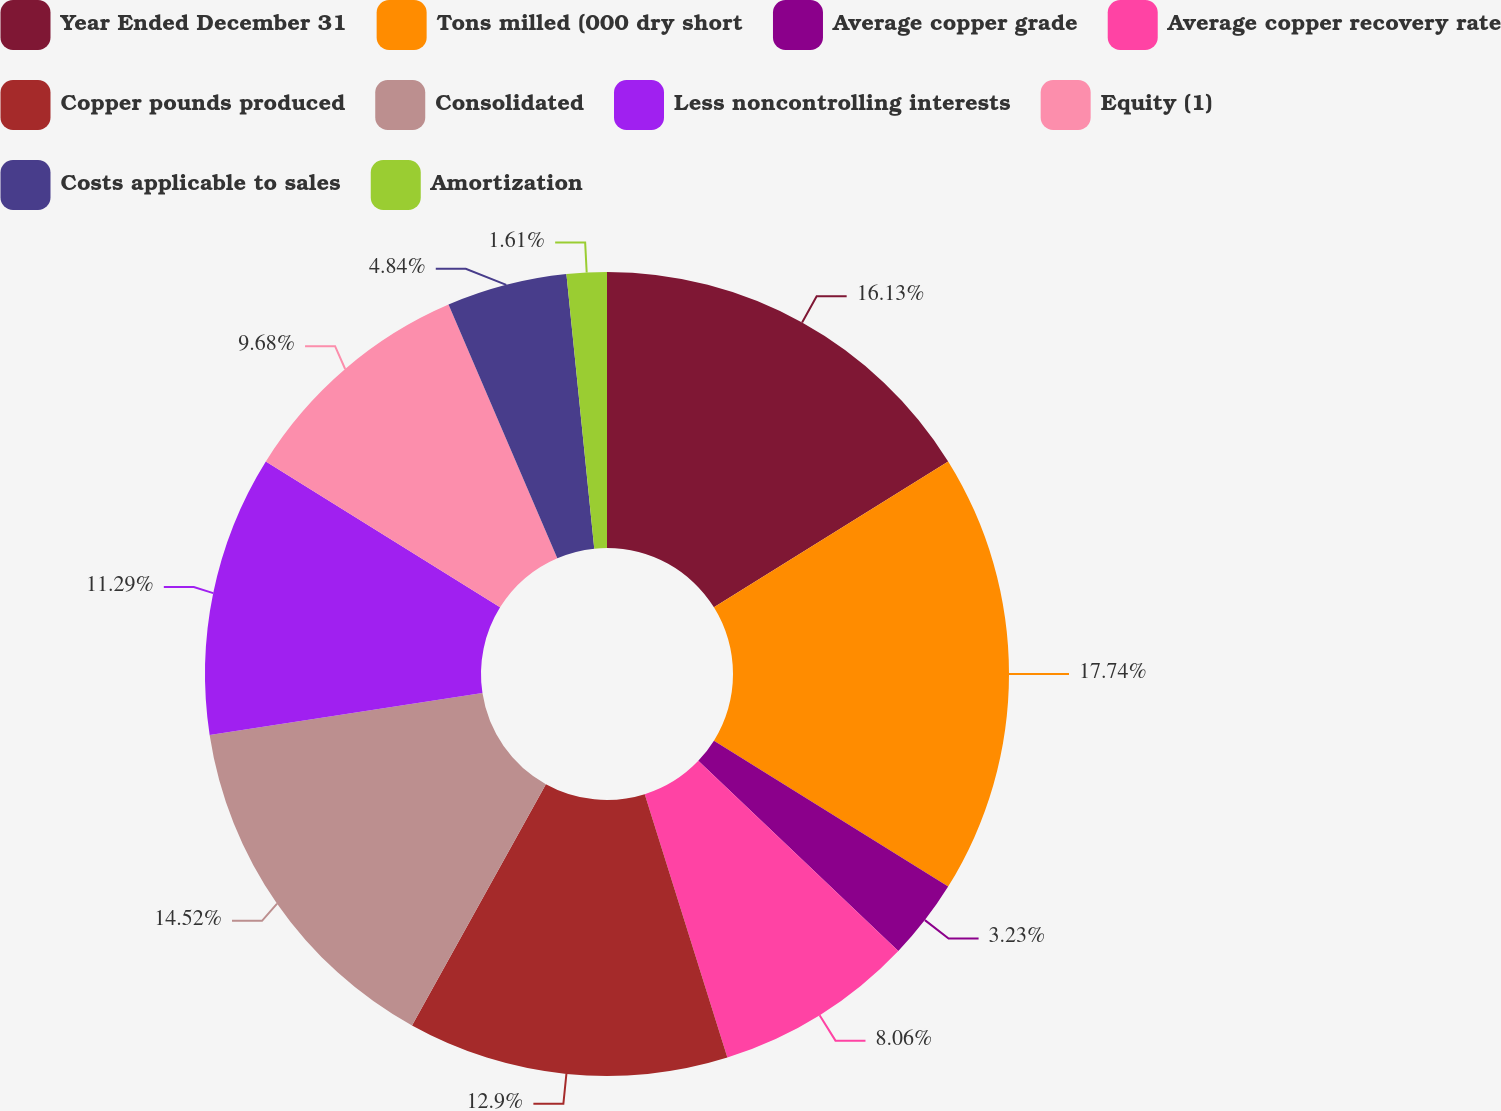Convert chart to OTSL. <chart><loc_0><loc_0><loc_500><loc_500><pie_chart><fcel>Year Ended December 31<fcel>Tons milled (000 dry short<fcel>Average copper grade<fcel>Average copper recovery rate<fcel>Copper pounds produced<fcel>Consolidated<fcel>Less noncontrolling interests<fcel>Equity (1)<fcel>Costs applicable to sales<fcel>Amortization<nl><fcel>16.13%<fcel>17.74%<fcel>3.23%<fcel>8.06%<fcel>12.9%<fcel>14.52%<fcel>11.29%<fcel>9.68%<fcel>4.84%<fcel>1.61%<nl></chart> 